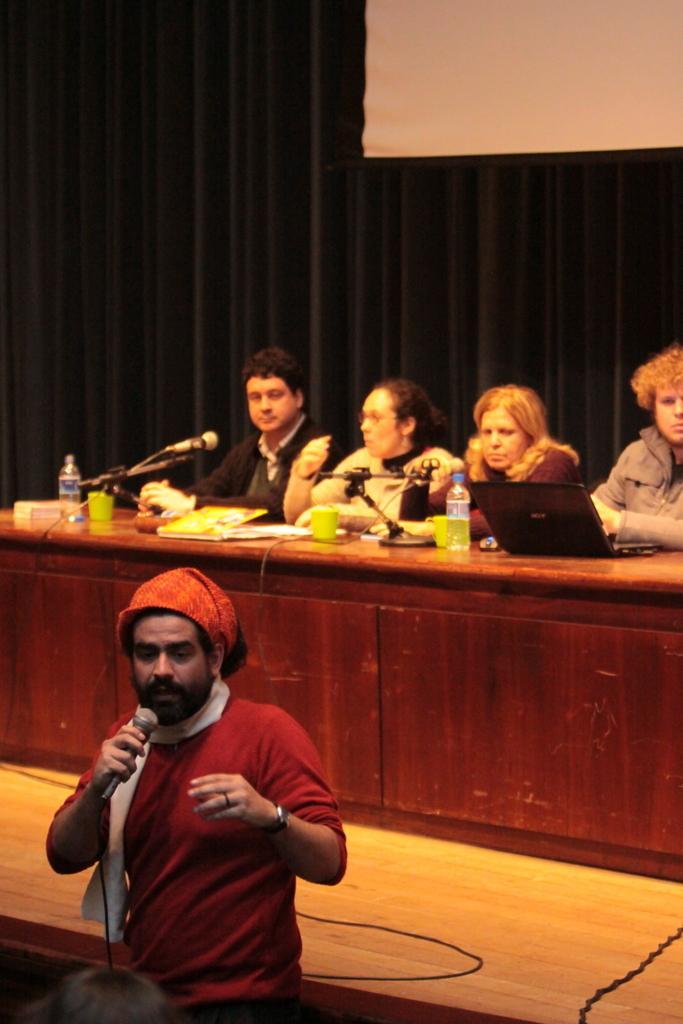In one or two sentences, can you explain what this image depicts? In the center of a picture there is a person holding a mic. In the background there is a projector screen and there is a curtain. In the center of the picture there is a disk, on the disk there are cups, mics, water bottles, books and laptop and there are people sitting on chairs. 